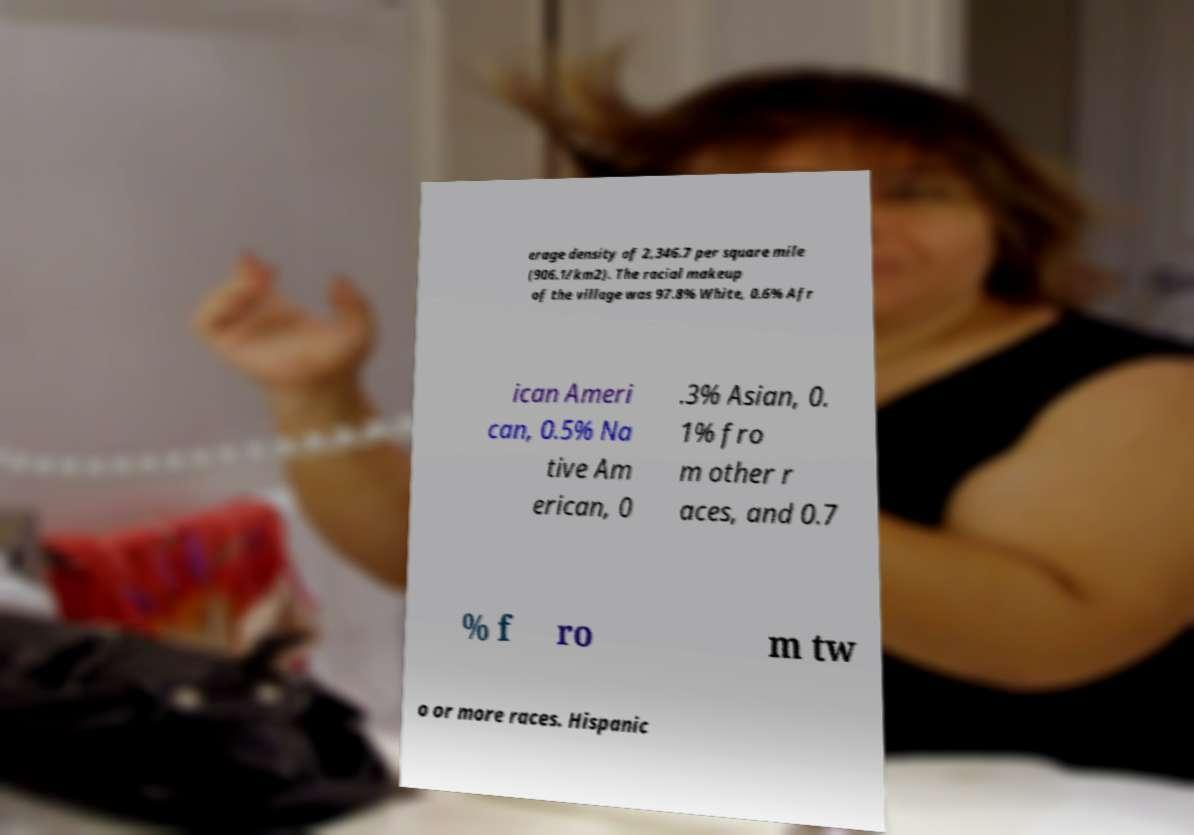Could you assist in decoding the text presented in this image and type it out clearly? erage density of 2,346.7 per square mile (906.1/km2). The racial makeup of the village was 97.8% White, 0.6% Afr ican Ameri can, 0.5% Na tive Am erican, 0 .3% Asian, 0. 1% fro m other r aces, and 0.7 % f ro m tw o or more races. Hispanic 